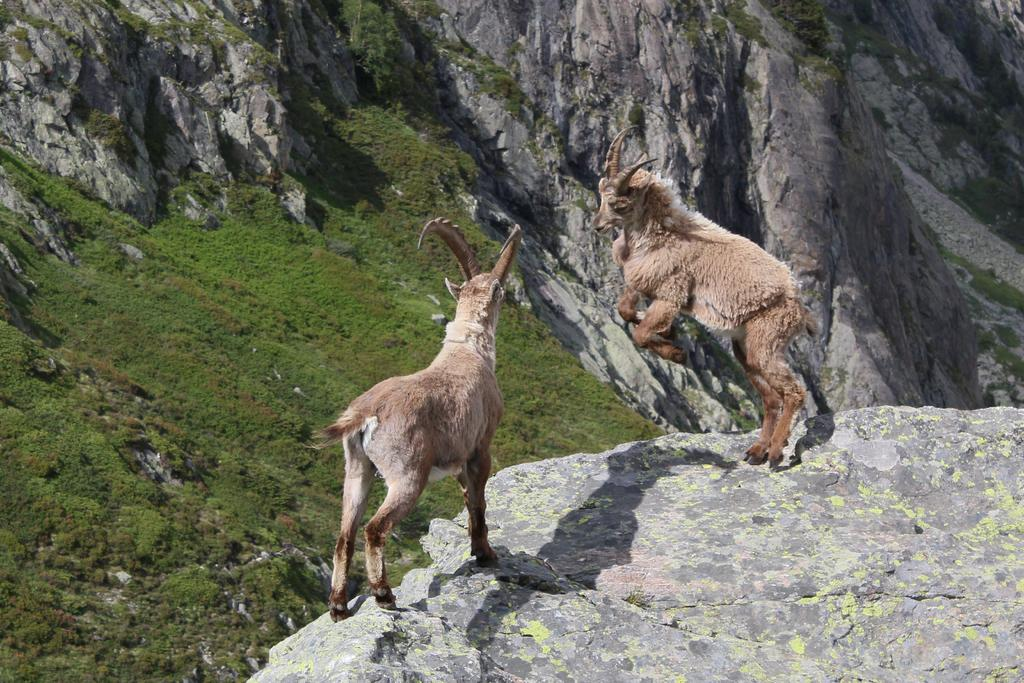How many animals are present in the image? There are two animals in the image. Where are the animals located? The animals are on a rocky mountain in the image. What type of vegetation can be seen on the rocky mountain? There is grass on the rocky mountains in the image. What type of hole can be seen in the image? There is no hole present in the image. What selection of animals is available in the image? The image only features two animals, so there is no selection of animals available. 